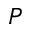<formula> <loc_0><loc_0><loc_500><loc_500>P</formula> 